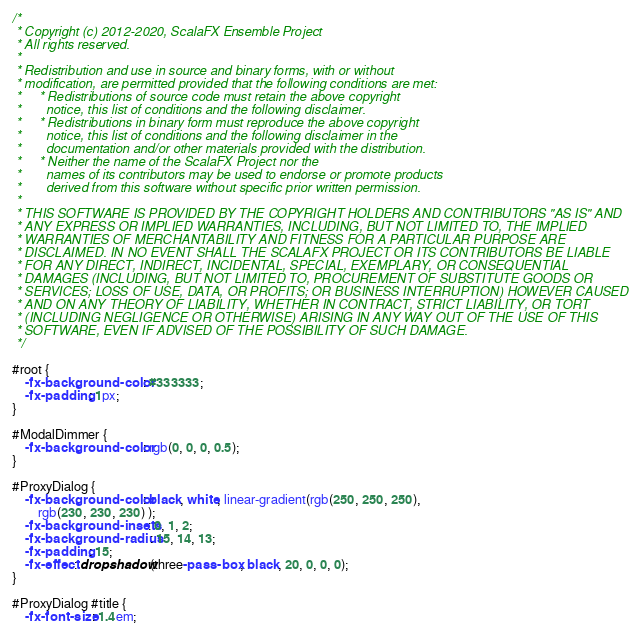Convert code to text. <code><loc_0><loc_0><loc_500><loc_500><_CSS_>/*
 * Copyright (c) 2012-2020, ScalaFX Ensemble Project
 * All rights reserved.
 *
 * Redistribution and use in source and binary forms, with or without
 * modification, are permitted provided that the following conditions are met:
 *     * Redistributions of source code must retain the above copyright
 *       notice, this list of conditions and the following disclaimer.
 *     * Redistributions in binary form must reproduce the above copyright
 *       notice, this list of conditions and the following disclaimer in the
 *       documentation and/or other materials provided with the distribution.
 *     * Neither the name of the ScalaFX Project nor the
 *       names of its contributors may be used to endorse or promote products
 *       derived from this software without specific prior written permission.
 *
 * THIS SOFTWARE IS PROVIDED BY THE COPYRIGHT HOLDERS AND CONTRIBUTORS "AS IS" AND
 * ANY EXPRESS OR IMPLIED WARRANTIES, INCLUDING, BUT NOT LIMITED TO, THE IMPLIED
 * WARRANTIES OF MERCHANTABILITY AND FITNESS FOR A PARTICULAR PURPOSE ARE
 * DISCLAIMED. IN NO EVENT SHALL THE SCALAFX PROJECT OR ITS CONTRIBUTORS BE LIABLE
 * FOR ANY DIRECT, INDIRECT, INCIDENTAL, SPECIAL, EXEMPLARY, OR CONSEQUENTIAL
 * DAMAGES (INCLUDING, BUT NOT LIMITED TO, PROCUREMENT OF SUBSTITUTE GOODS OR
 * SERVICES; LOSS OF USE, DATA, OR PROFITS; OR BUSINESS INTERRUPTION) HOWEVER CAUSED
 * AND ON ANY THEORY OF LIABILITY, WHETHER IN CONTRACT, STRICT LIABILITY, OR TORT
 * (INCLUDING NEGLIGENCE OR OTHERWISE) ARISING IN ANY WAY OUT OF THE USE OF THIS
 * SOFTWARE, EVEN IF ADVISED OF THE POSSIBILITY OF SUCH DAMAGE.
 */

#root {
	-fx-background-color: #333333;
	-fx-padding: 1px;
}

#ModalDimmer {
	-fx-background-color: rgb(0, 0, 0, 0.5);
}

#ProxyDialog {
	-fx-background-color: black, white, linear-gradient(rgb(250, 250, 250),
		rgb(230, 230, 230) );
	-fx-background-insets: 0, 1, 2;
	-fx-background-radius: 15, 14, 13;
	-fx-padding: 15;
	-fx-effect: dropshadow(three-pass-box, black, 20, 0, 0, 0);
}

#ProxyDialog #title {
	-fx-font-size: 1.4em;</code> 